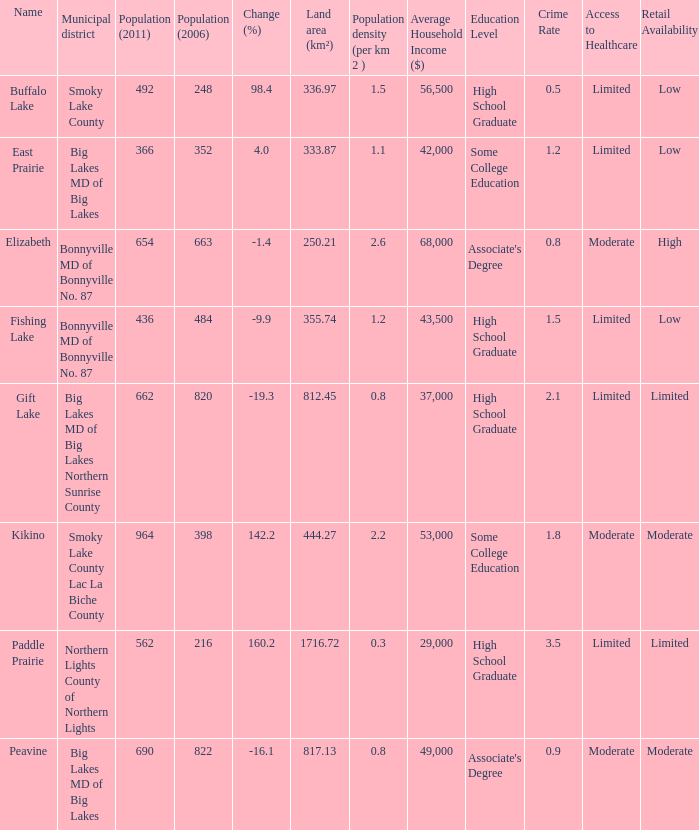What is the population density in Buffalo Lake? 1.5. 